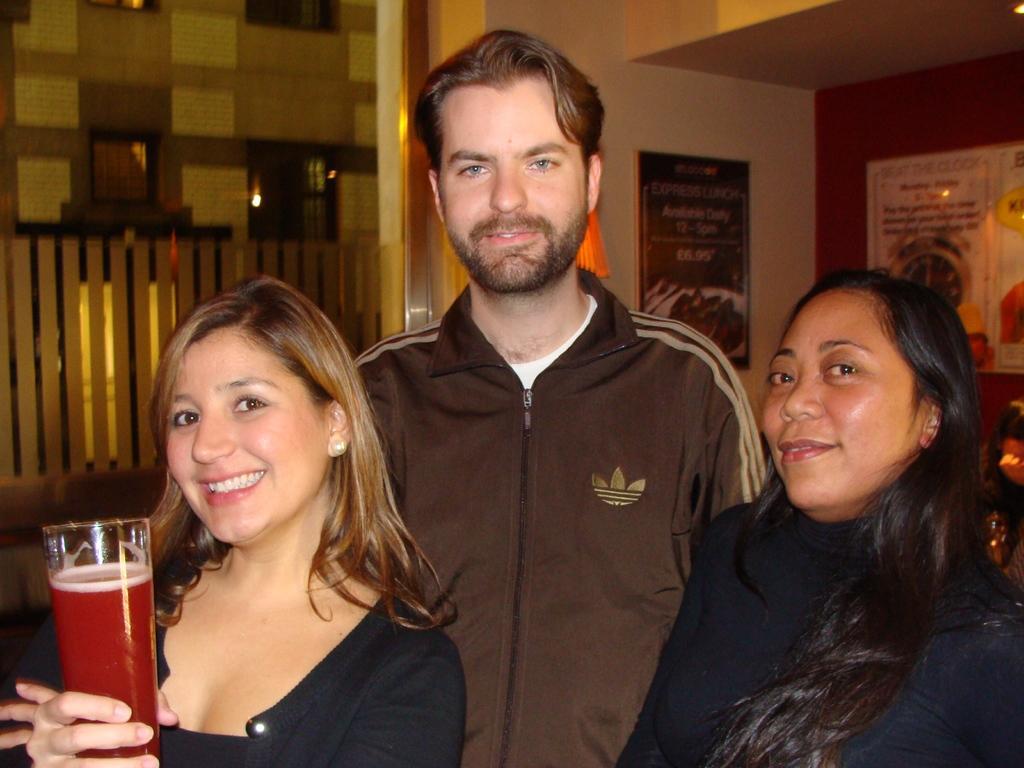In one or two sentences, can you explain what this image depicts? In the image there are three people,two women and man and three of them are posing for the photo and the woman standing in the left is holding a glass with some drink and in the background there is a wall and there are some posters to the wall. 